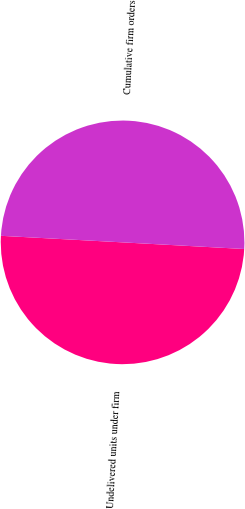Convert chart. <chart><loc_0><loc_0><loc_500><loc_500><pie_chart><fcel>Undelivered units under firm<fcel>Cumulative firm orders<nl><fcel>49.99%<fcel>50.01%<nl></chart> 